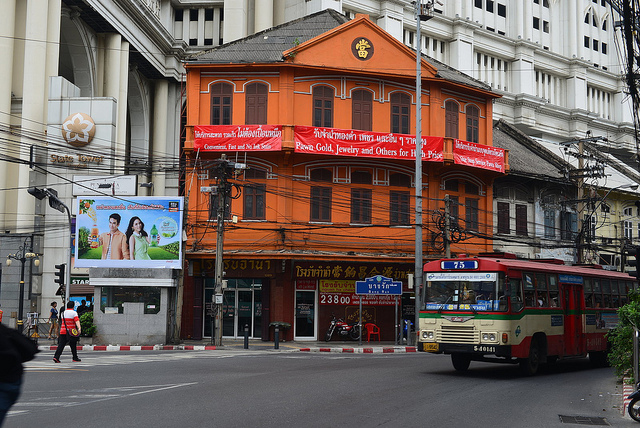Identify the text displayed in this image. Gold 75 DO 238 STAR for Others 